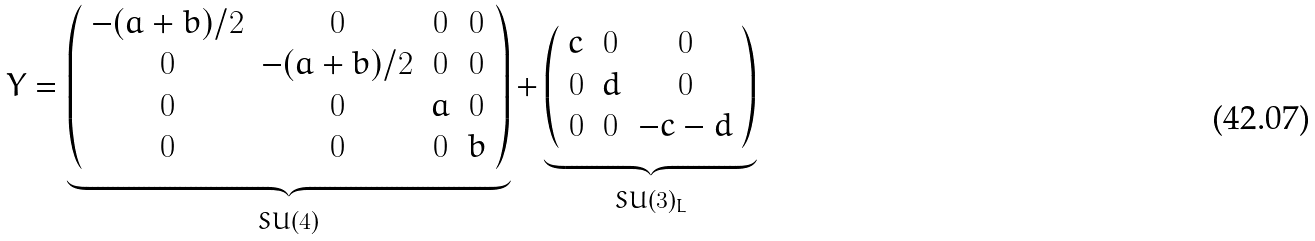<formula> <loc_0><loc_0><loc_500><loc_500>Y = \underbrace { \left ( \begin{array} { c c c c } - ( a + b ) / 2 & 0 & 0 & 0 \\ 0 & - ( a + b ) / 2 & 0 & 0 \\ 0 & 0 & a & 0 \\ 0 & 0 & 0 & b \end{array} \right ) } _ { S U ( 4 ) } + \underbrace { \left ( \begin{array} { c c c } c & 0 & 0 \\ 0 & d & 0 \\ 0 & 0 & - c - d \end{array} \right ) } _ { S U ( 3 ) _ { L } }</formula> 